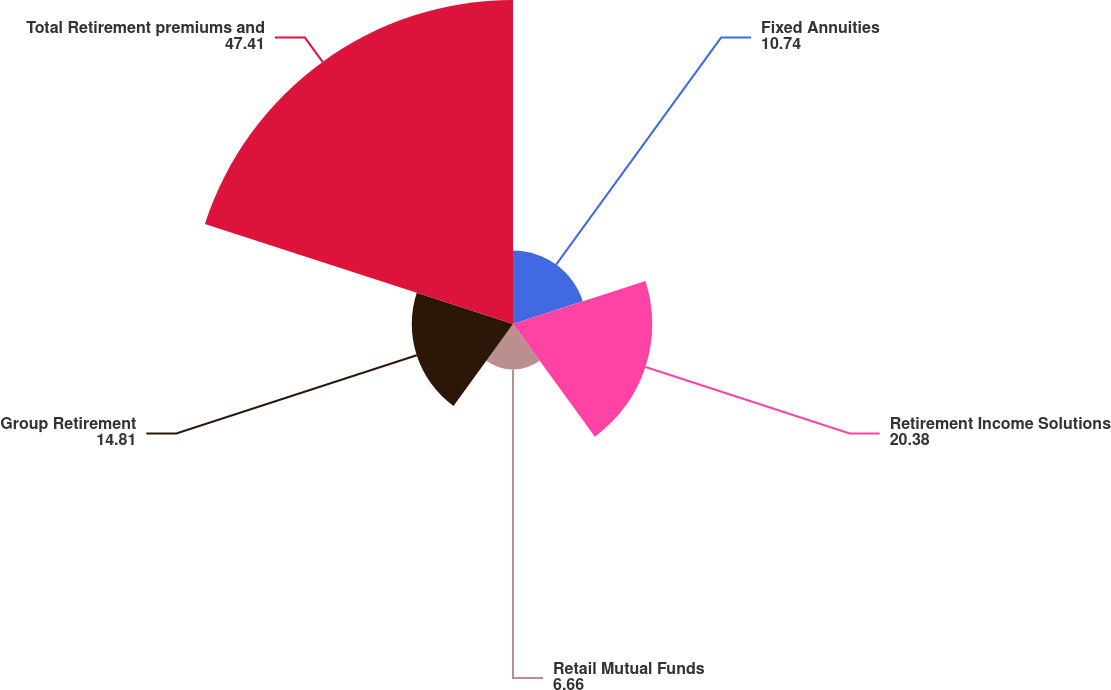<chart> <loc_0><loc_0><loc_500><loc_500><pie_chart><fcel>Fixed Annuities<fcel>Retirement Income Solutions<fcel>Retail Mutual Funds<fcel>Group Retirement<fcel>Total Retirement premiums and<nl><fcel>10.74%<fcel>20.38%<fcel>6.66%<fcel>14.81%<fcel>47.41%<nl></chart> 